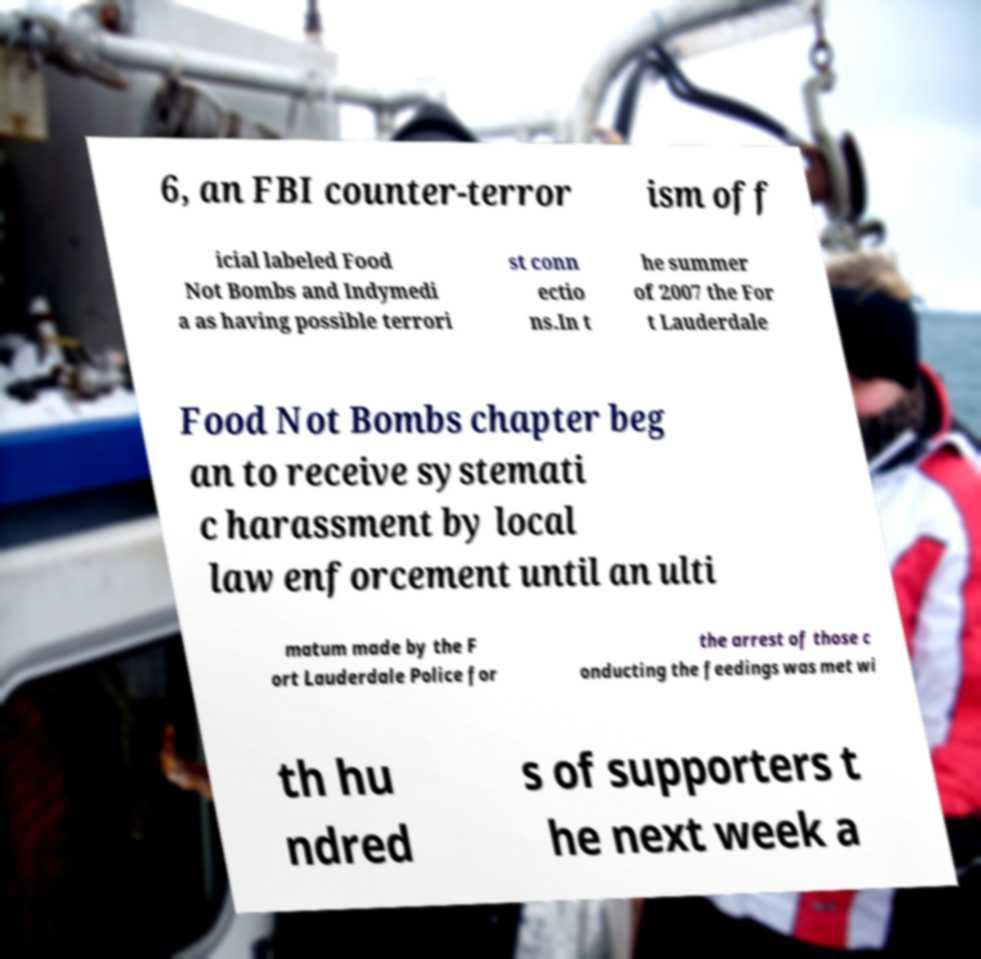Please identify and transcribe the text found in this image. 6, an FBI counter-terror ism off icial labeled Food Not Bombs and Indymedi a as having possible terrori st conn ectio ns.In t he summer of 2007 the For t Lauderdale Food Not Bombs chapter beg an to receive systemati c harassment by local law enforcement until an ulti matum made by the F ort Lauderdale Police for the arrest of those c onducting the feedings was met wi th hu ndred s of supporters t he next week a 